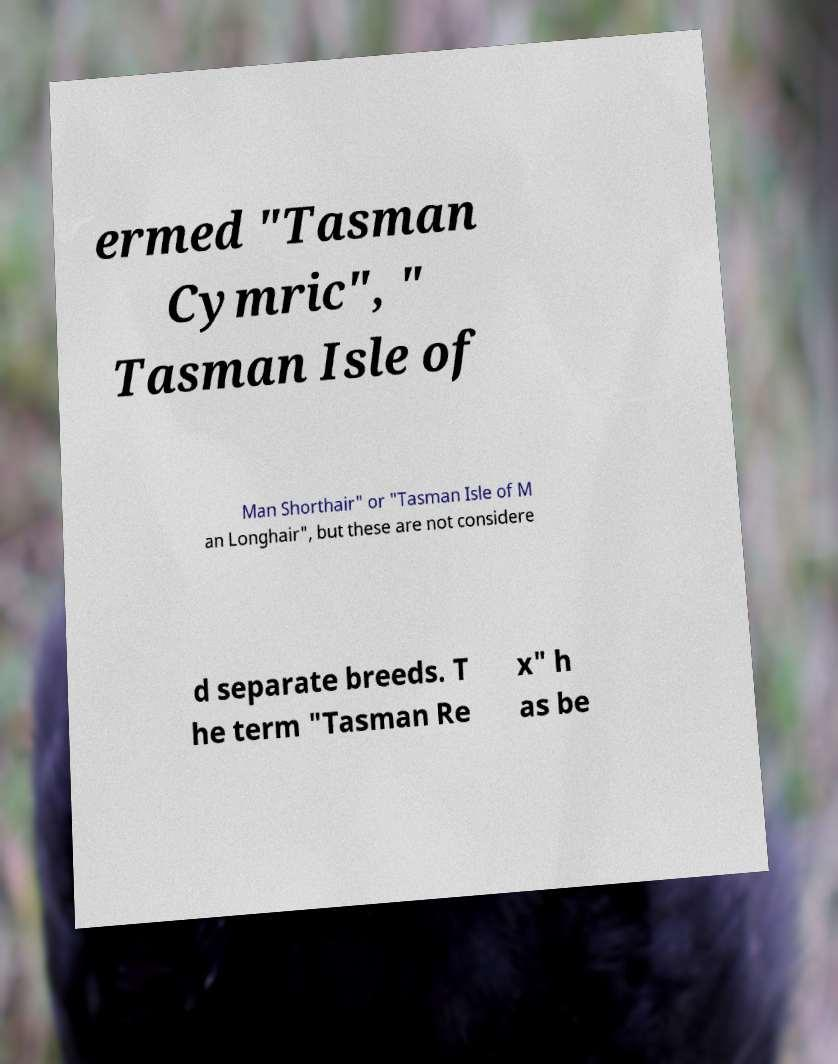There's text embedded in this image that I need extracted. Can you transcribe it verbatim? ermed "Tasman Cymric", " Tasman Isle of Man Shorthair" or "Tasman Isle of M an Longhair", but these are not considere d separate breeds. T he term "Tasman Re x" h as be 